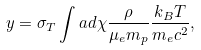Convert formula to latex. <formula><loc_0><loc_0><loc_500><loc_500>y = \sigma _ { T } \int a d \chi \frac { \rho } { \mu _ { e } m _ { p } } \frac { k _ { B } T } { m _ { e } c ^ { 2 } } ,</formula> 